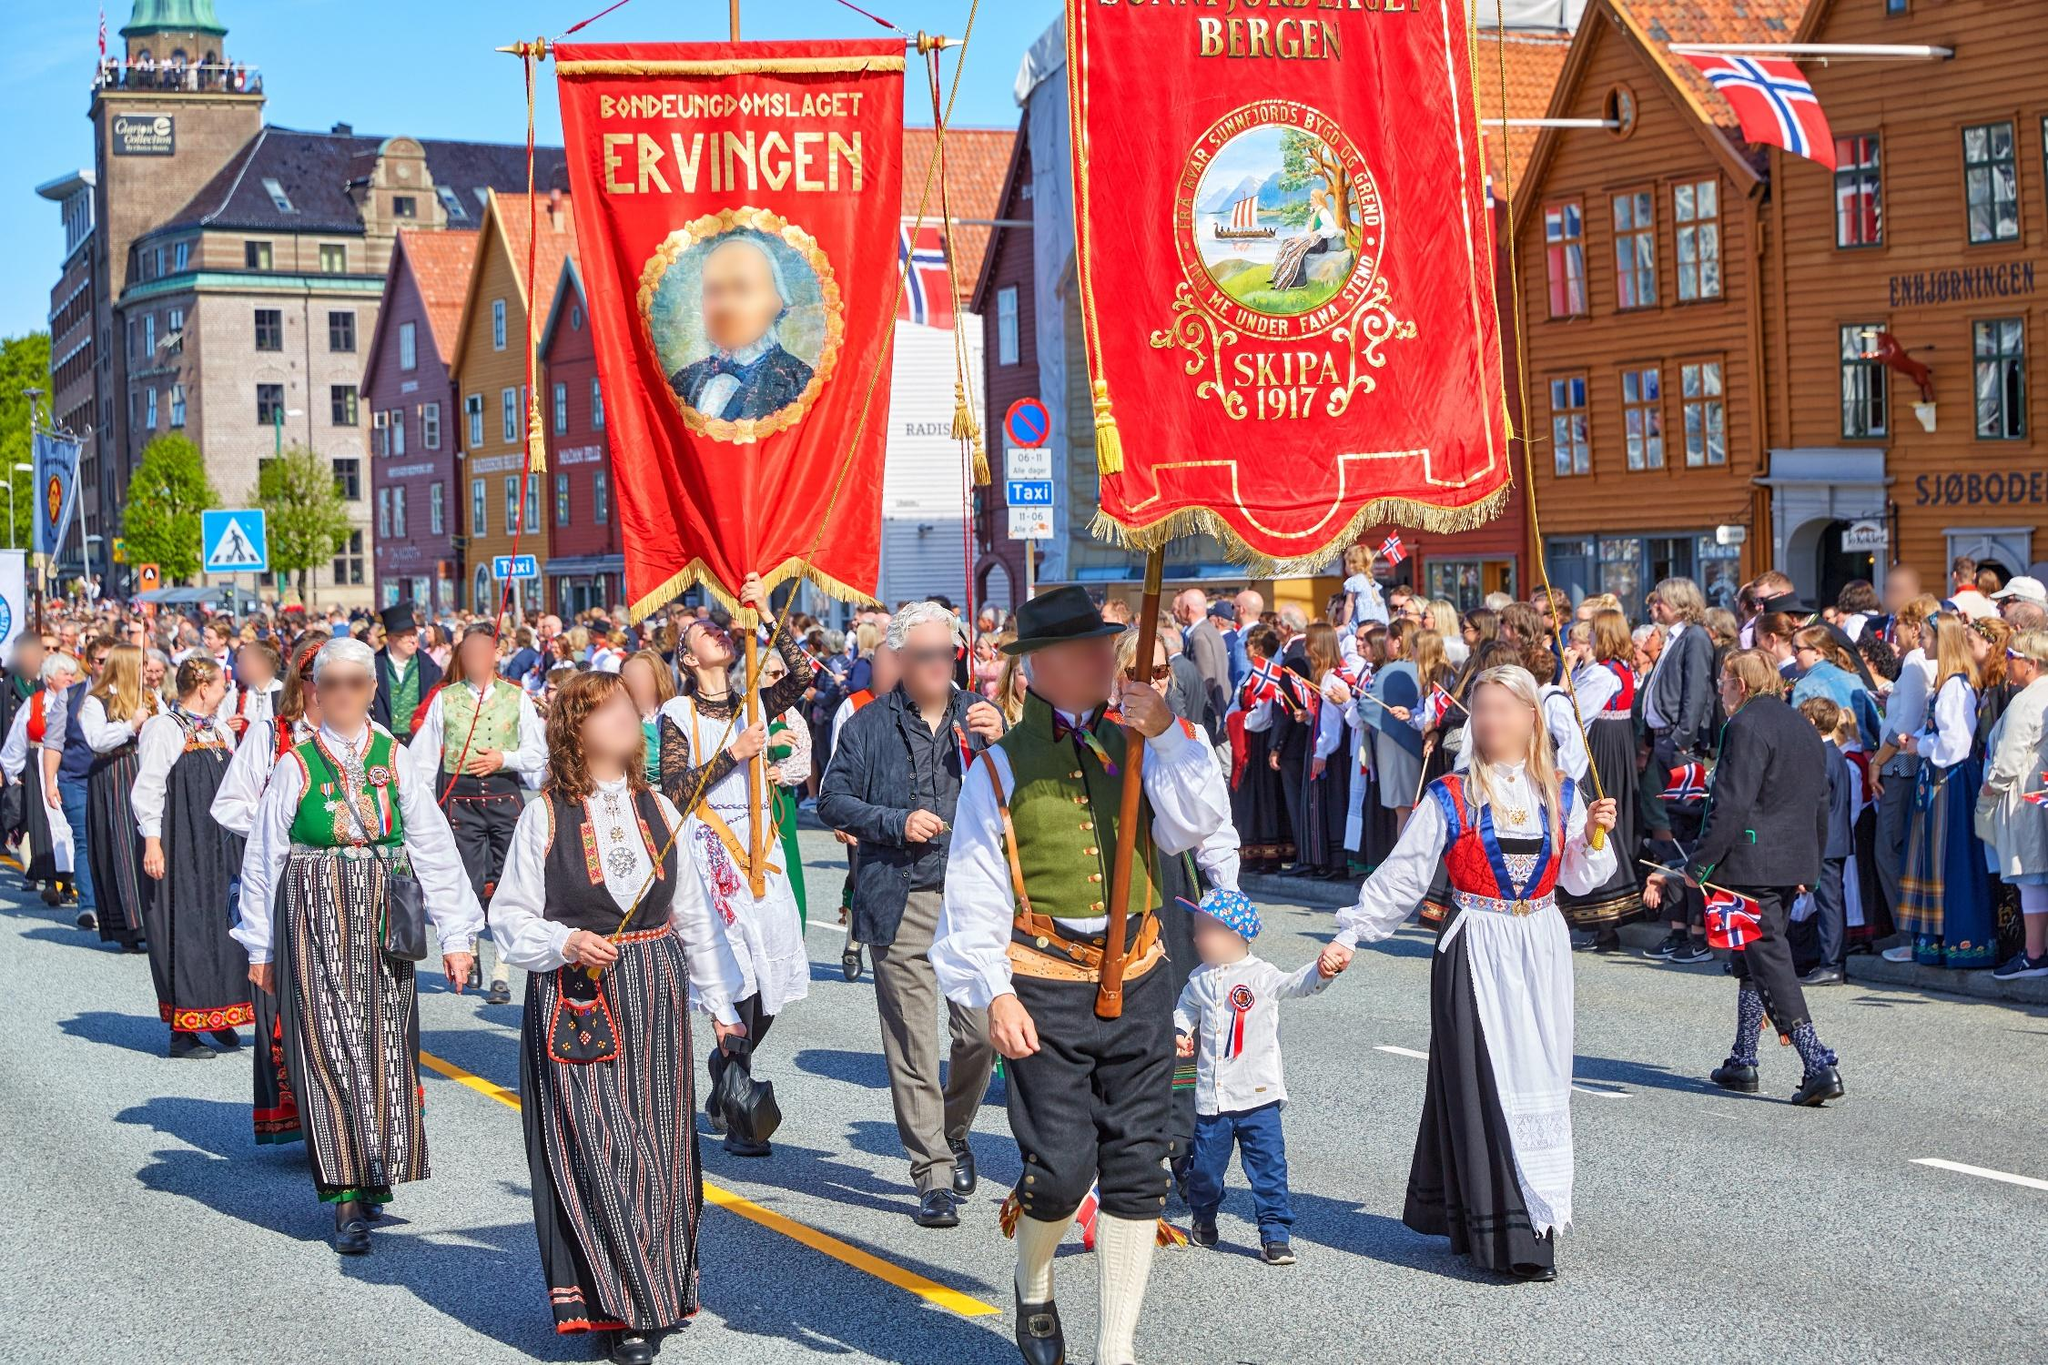Imagine this parade is happening in the year 2317. How might it be different? In the year 2317, a parade in Bergen might blend traditional elements with futuristic technology. Participants could be wearing advanced, eco-friendly versions of bunads that integrate smart fabrics with digital embroidery telling interactive stories. Holographic banners might hover in the air, displaying dynamic scenes from Bergen’s history. The parade might also incorporate augmented reality spectacles, allowing onlookers to witness historical reenactments overlaid on the real-world scene. Despite the technological advancements, the core elements of cultural pride and community spirit would remain unchanged, reflecting a deep respect for heritage, even in the distant future. 